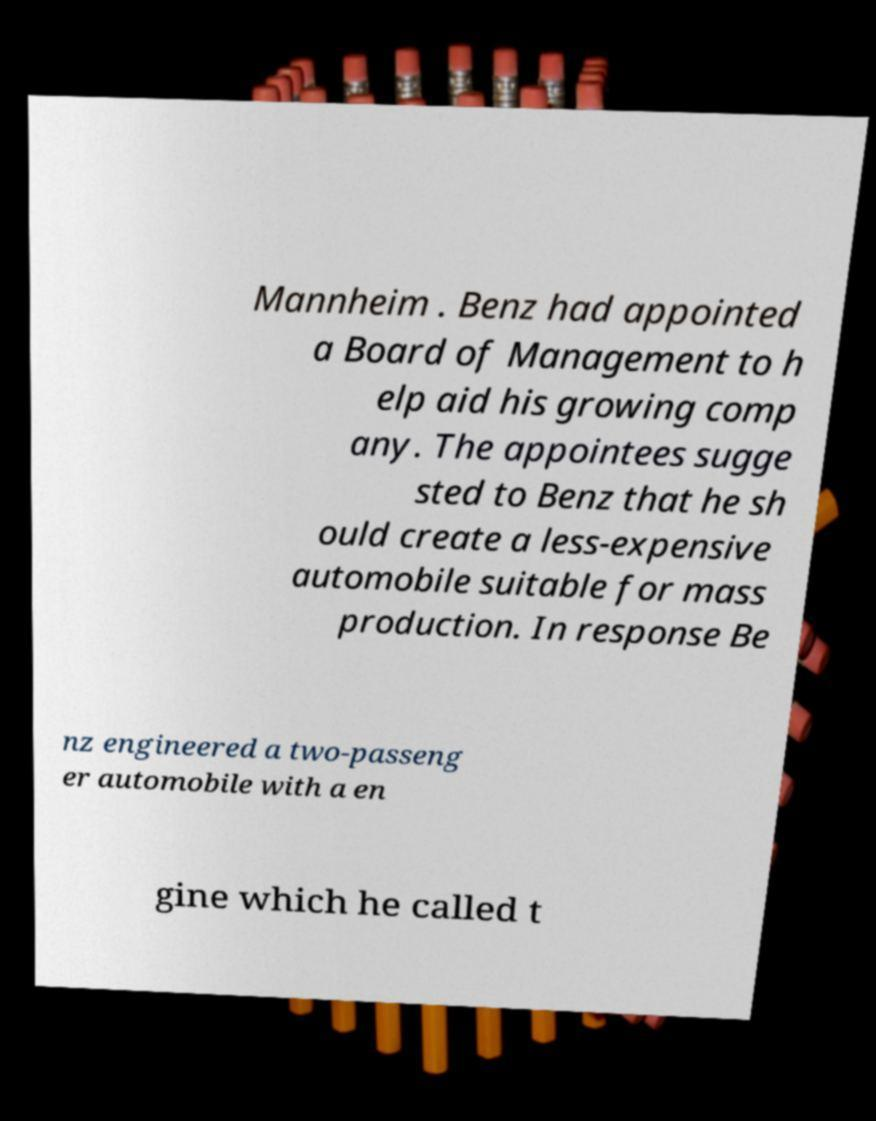For documentation purposes, I need the text within this image transcribed. Could you provide that? Mannheim . Benz had appointed a Board of Management to h elp aid his growing comp any. The appointees sugge sted to Benz that he sh ould create a less-expensive automobile suitable for mass production. In response Be nz engineered a two-passeng er automobile with a en gine which he called t 